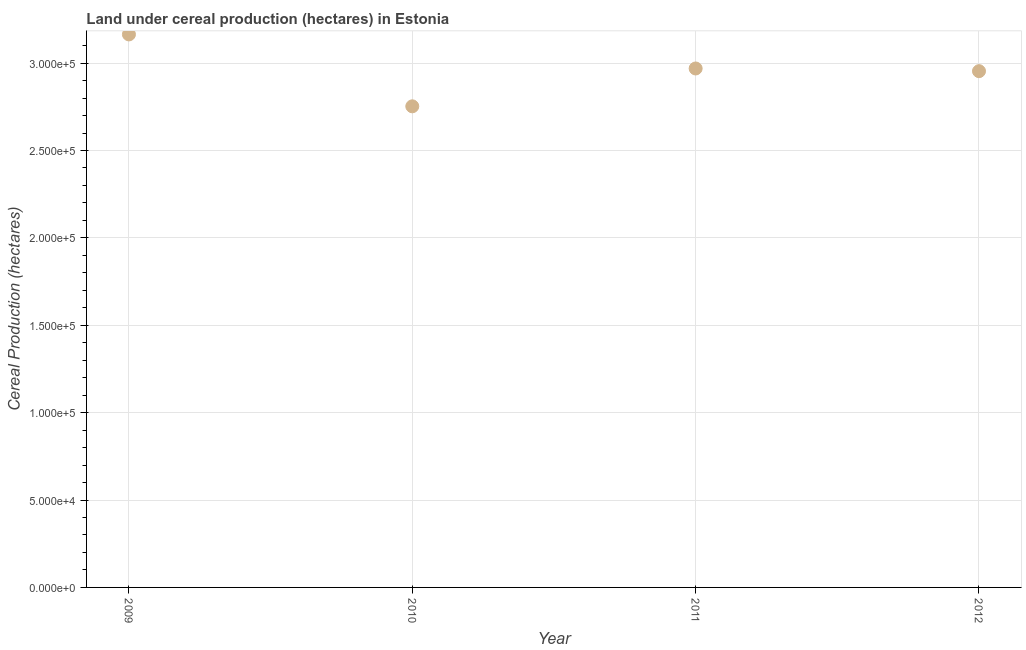What is the land under cereal production in 2012?
Keep it short and to the point. 2.95e+05. Across all years, what is the maximum land under cereal production?
Keep it short and to the point. 3.16e+05. Across all years, what is the minimum land under cereal production?
Provide a short and direct response. 2.75e+05. In which year was the land under cereal production maximum?
Keep it short and to the point. 2009. In which year was the land under cereal production minimum?
Your answer should be very brief. 2010. What is the sum of the land under cereal production?
Provide a succinct answer. 1.18e+06. What is the difference between the land under cereal production in 2009 and 2011?
Your response must be concise. 1.95e+04. What is the average land under cereal production per year?
Offer a terse response. 2.96e+05. What is the median land under cereal production?
Provide a succinct answer. 2.96e+05. In how many years, is the land under cereal production greater than 270000 hectares?
Your response must be concise. 4. What is the ratio of the land under cereal production in 2009 to that in 2010?
Provide a succinct answer. 1.15. Is the land under cereal production in 2011 less than that in 2012?
Provide a short and direct response. No. Is the difference between the land under cereal production in 2010 and 2012 greater than the difference between any two years?
Your answer should be compact. No. What is the difference between the highest and the second highest land under cereal production?
Provide a short and direct response. 1.95e+04. Is the sum of the land under cereal production in 2010 and 2012 greater than the maximum land under cereal production across all years?
Keep it short and to the point. Yes. What is the difference between the highest and the lowest land under cereal production?
Give a very brief answer. 4.11e+04. How many dotlines are there?
Offer a very short reply. 1. Are the values on the major ticks of Y-axis written in scientific E-notation?
Offer a terse response. Yes. Does the graph contain any zero values?
Offer a terse response. No. Does the graph contain grids?
Keep it short and to the point. Yes. What is the title of the graph?
Provide a succinct answer. Land under cereal production (hectares) in Estonia. What is the label or title of the X-axis?
Ensure brevity in your answer.  Year. What is the label or title of the Y-axis?
Provide a succinct answer. Cereal Production (hectares). What is the Cereal Production (hectares) in 2009?
Offer a terse response. 3.16e+05. What is the Cereal Production (hectares) in 2010?
Your answer should be compact. 2.75e+05. What is the Cereal Production (hectares) in 2011?
Provide a short and direct response. 2.97e+05. What is the Cereal Production (hectares) in 2012?
Offer a terse response. 2.95e+05. What is the difference between the Cereal Production (hectares) in 2009 and 2010?
Your answer should be compact. 4.11e+04. What is the difference between the Cereal Production (hectares) in 2009 and 2011?
Make the answer very short. 1.95e+04. What is the difference between the Cereal Production (hectares) in 2009 and 2012?
Your response must be concise. 2.10e+04. What is the difference between the Cereal Production (hectares) in 2010 and 2011?
Your response must be concise. -2.16e+04. What is the difference between the Cereal Production (hectares) in 2010 and 2012?
Your answer should be very brief. -2.01e+04. What is the difference between the Cereal Production (hectares) in 2011 and 2012?
Offer a terse response. 1531. What is the ratio of the Cereal Production (hectares) in 2009 to that in 2010?
Make the answer very short. 1.15. What is the ratio of the Cereal Production (hectares) in 2009 to that in 2011?
Offer a terse response. 1.07. What is the ratio of the Cereal Production (hectares) in 2009 to that in 2012?
Your response must be concise. 1.07. What is the ratio of the Cereal Production (hectares) in 2010 to that in 2011?
Offer a terse response. 0.93. What is the ratio of the Cereal Production (hectares) in 2010 to that in 2012?
Offer a terse response. 0.93. What is the ratio of the Cereal Production (hectares) in 2011 to that in 2012?
Give a very brief answer. 1. 